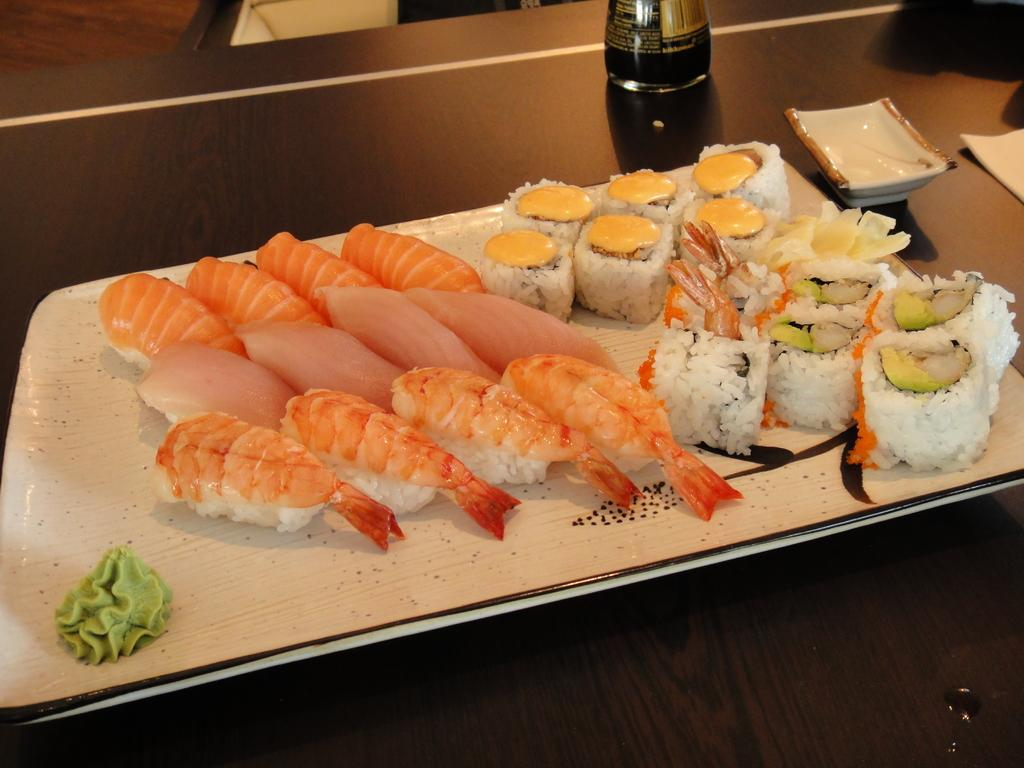What is in the center of the image? There is a plate in the center of the image. What types of food are on the plate? There are shrimps, meat, and sushi rolls on the plate. What other items can be seen in the image besides the plate? There is a bowl and a bottle in the image. Where are all the items placed? All items are placed on a table. What type of carriage can be seen in the image? There is no carriage present in the image. What attraction is visible in the background of the image? There is no attraction visible in the image; it only shows a plate with food, a bowl, a bottle, and a table. 